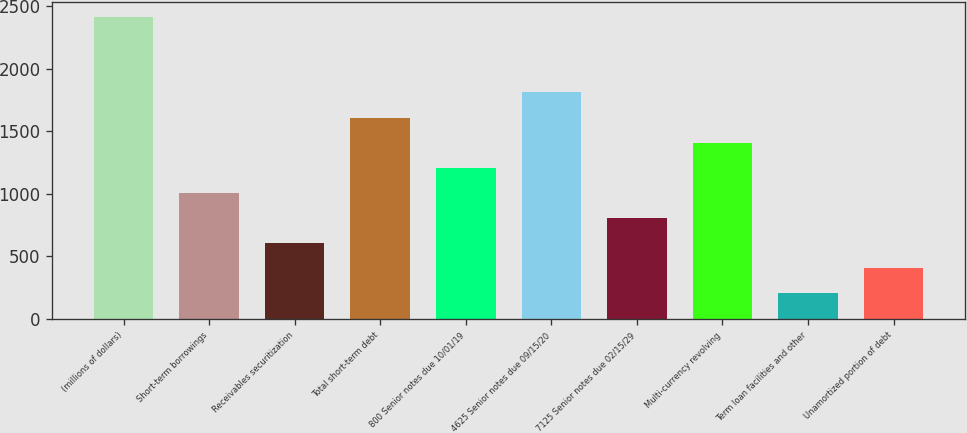Convert chart to OTSL. <chart><loc_0><loc_0><loc_500><loc_500><bar_chart><fcel>(millions of dollars)<fcel>Short-term borrowings<fcel>Receivables securitization<fcel>Total short-term debt<fcel>800 Senior notes due 10/01/19<fcel>4625 Senior notes due 09/15/20<fcel>7125 Senior notes due 02/15/29<fcel>Multi-currency revolving<fcel>Term loan facilities and other<fcel>Unamortized portion of debt<nl><fcel>2413.54<fcel>1008.15<fcel>606.61<fcel>1610.46<fcel>1208.92<fcel>1811.23<fcel>807.38<fcel>1409.69<fcel>205.07<fcel>405.84<nl></chart> 